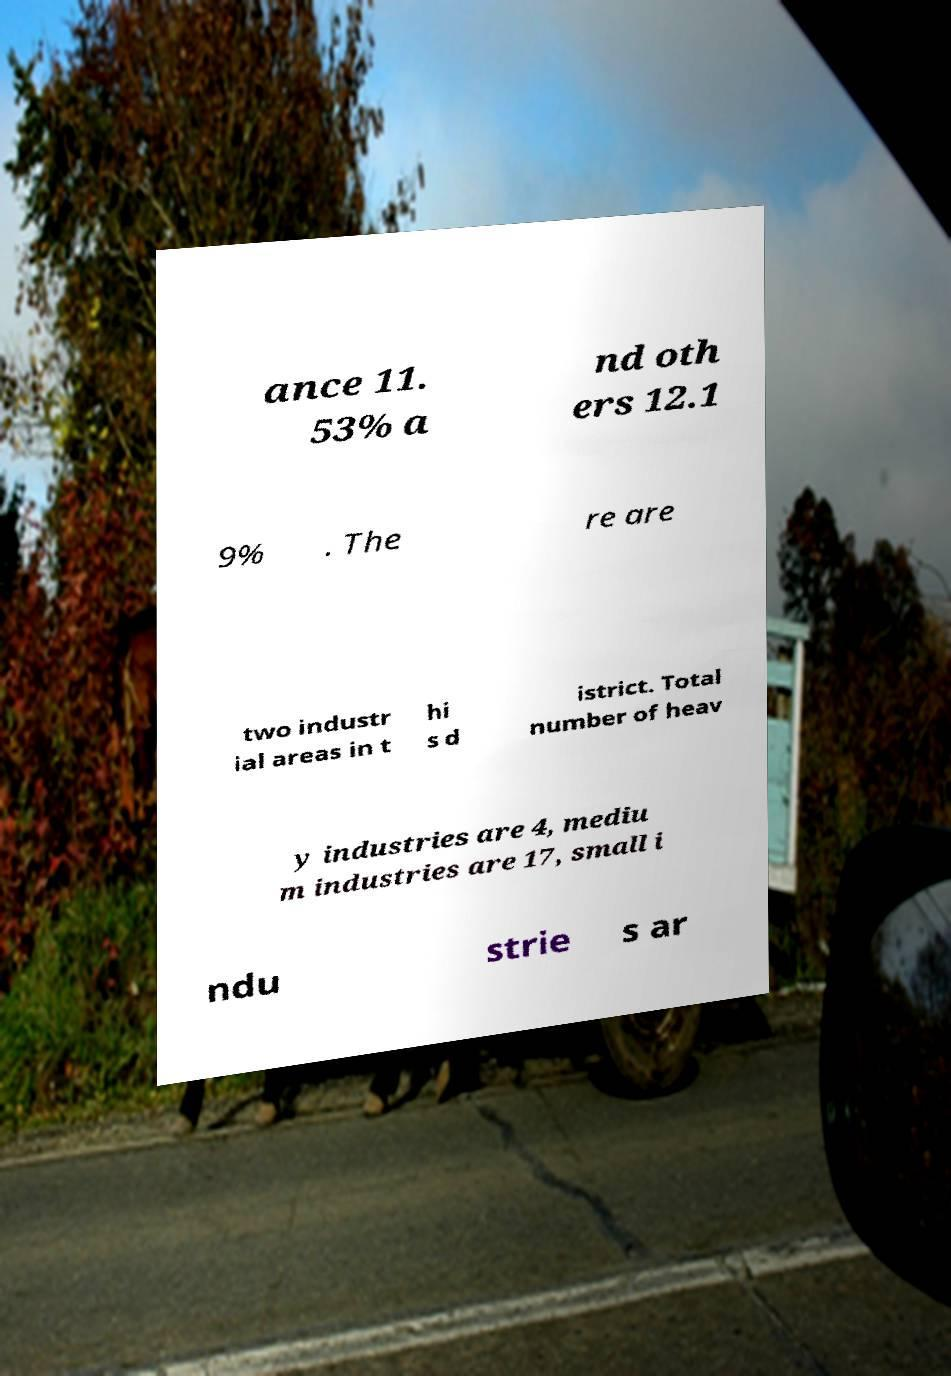Could you assist in decoding the text presented in this image and type it out clearly? ance 11. 53% a nd oth ers 12.1 9% . The re are two industr ial areas in t hi s d istrict. Total number of heav y industries are 4, mediu m industries are 17, small i ndu strie s ar 